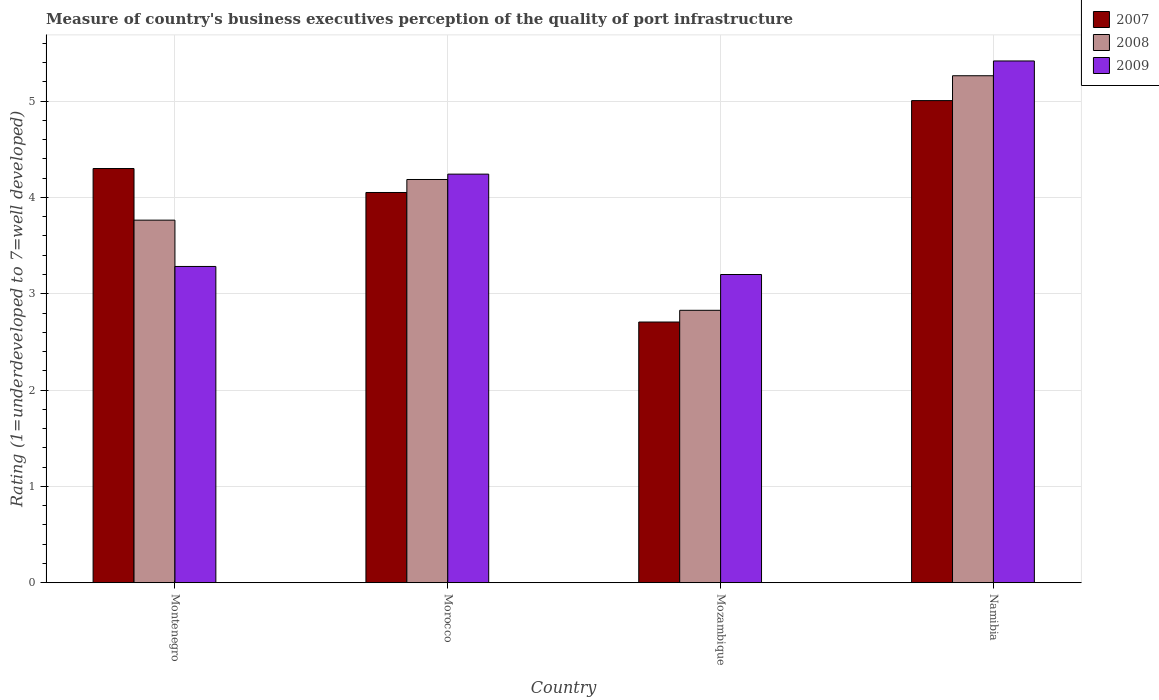How many groups of bars are there?
Give a very brief answer. 4. Are the number of bars on each tick of the X-axis equal?
Keep it short and to the point. Yes. How many bars are there on the 2nd tick from the left?
Your answer should be compact. 3. What is the label of the 1st group of bars from the left?
Your answer should be very brief. Montenegro. In how many cases, is the number of bars for a given country not equal to the number of legend labels?
Ensure brevity in your answer.  0. What is the ratings of the quality of port infrastructure in 2007 in Morocco?
Make the answer very short. 4.05. Across all countries, what is the maximum ratings of the quality of port infrastructure in 2009?
Give a very brief answer. 5.42. Across all countries, what is the minimum ratings of the quality of port infrastructure in 2009?
Offer a terse response. 3.2. In which country was the ratings of the quality of port infrastructure in 2007 maximum?
Give a very brief answer. Namibia. In which country was the ratings of the quality of port infrastructure in 2008 minimum?
Make the answer very short. Mozambique. What is the total ratings of the quality of port infrastructure in 2008 in the graph?
Keep it short and to the point. 16.04. What is the difference between the ratings of the quality of port infrastructure in 2009 in Montenegro and that in Mozambique?
Give a very brief answer. 0.08. What is the difference between the ratings of the quality of port infrastructure in 2009 in Montenegro and the ratings of the quality of port infrastructure in 2008 in Mozambique?
Give a very brief answer. 0.46. What is the average ratings of the quality of port infrastructure in 2008 per country?
Offer a very short reply. 4.01. What is the difference between the ratings of the quality of port infrastructure of/in 2008 and ratings of the quality of port infrastructure of/in 2007 in Montenegro?
Your answer should be very brief. -0.54. What is the ratio of the ratings of the quality of port infrastructure in 2007 in Montenegro to that in Namibia?
Your response must be concise. 0.86. Is the difference between the ratings of the quality of port infrastructure in 2008 in Montenegro and Namibia greater than the difference between the ratings of the quality of port infrastructure in 2007 in Montenegro and Namibia?
Offer a very short reply. No. What is the difference between the highest and the second highest ratings of the quality of port infrastructure in 2008?
Make the answer very short. -0.42. What is the difference between the highest and the lowest ratings of the quality of port infrastructure in 2009?
Keep it short and to the point. 2.22. In how many countries, is the ratings of the quality of port infrastructure in 2008 greater than the average ratings of the quality of port infrastructure in 2008 taken over all countries?
Your response must be concise. 2. Is it the case that in every country, the sum of the ratings of the quality of port infrastructure in 2008 and ratings of the quality of port infrastructure in 2009 is greater than the ratings of the quality of port infrastructure in 2007?
Provide a succinct answer. Yes. What is the difference between two consecutive major ticks on the Y-axis?
Your response must be concise. 1. What is the title of the graph?
Offer a very short reply. Measure of country's business executives perception of the quality of port infrastructure. What is the label or title of the Y-axis?
Offer a very short reply. Rating (1=underdeveloped to 7=well developed). What is the Rating (1=underdeveloped to 7=well developed) in 2007 in Montenegro?
Give a very brief answer. 4.3. What is the Rating (1=underdeveloped to 7=well developed) in 2008 in Montenegro?
Provide a short and direct response. 3.76. What is the Rating (1=underdeveloped to 7=well developed) of 2009 in Montenegro?
Ensure brevity in your answer.  3.28. What is the Rating (1=underdeveloped to 7=well developed) in 2007 in Morocco?
Give a very brief answer. 4.05. What is the Rating (1=underdeveloped to 7=well developed) of 2008 in Morocco?
Your answer should be very brief. 4.19. What is the Rating (1=underdeveloped to 7=well developed) of 2009 in Morocco?
Provide a short and direct response. 4.24. What is the Rating (1=underdeveloped to 7=well developed) of 2007 in Mozambique?
Ensure brevity in your answer.  2.71. What is the Rating (1=underdeveloped to 7=well developed) of 2008 in Mozambique?
Provide a succinct answer. 2.83. What is the Rating (1=underdeveloped to 7=well developed) of 2009 in Mozambique?
Offer a terse response. 3.2. What is the Rating (1=underdeveloped to 7=well developed) in 2007 in Namibia?
Offer a very short reply. 5.01. What is the Rating (1=underdeveloped to 7=well developed) of 2008 in Namibia?
Ensure brevity in your answer.  5.26. What is the Rating (1=underdeveloped to 7=well developed) of 2009 in Namibia?
Ensure brevity in your answer.  5.42. Across all countries, what is the maximum Rating (1=underdeveloped to 7=well developed) in 2007?
Your response must be concise. 5.01. Across all countries, what is the maximum Rating (1=underdeveloped to 7=well developed) in 2008?
Your answer should be very brief. 5.26. Across all countries, what is the maximum Rating (1=underdeveloped to 7=well developed) of 2009?
Ensure brevity in your answer.  5.42. Across all countries, what is the minimum Rating (1=underdeveloped to 7=well developed) of 2007?
Provide a short and direct response. 2.71. Across all countries, what is the minimum Rating (1=underdeveloped to 7=well developed) of 2008?
Provide a succinct answer. 2.83. Across all countries, what is the minimum Rating (1=underdeveloped to 7=well developed) in 2009?
Ensure brevity in your answer.  3.2. What is the total Rating (1=underdeveloped to 7=well developed) of 2007 in the graph?
Offer a very short reply. 16.06. What is the total Rating (1=underdeveloped to 7=well developed) in 2008 in the graph?
Provide a succinct answer. 16.04. What is the total Rating (1=underdeveloped to 7=well developed) of 2009 in the graph?
Give a very brief answer. 16.14. What is the difference between the Rating (1=underdeveloped to 7=well developed) of 2007 in Montenegro and that in Morocco?
Ensure brevity in your answer.  0.25. What is the difference between the Rating (1=underdeveloped to 7=well developed) of 2008 in Montenegro and that in Morocco?
Your answer should be very brief. -0.42. What is the difference between the Rating (1=underdeveloped to 7=well developed) in 2009 in Montenegro and that in Morocco?
Your response must be concise. -0.96. What is the difference between the Rating (1=underdeveloped to 7=well developed) in 2007 in Montenegro and that in Mozambique?
Give a very brief answer. 1.59. What is the difference between the Rating (1=underdeveloped to 7=well developed) of 2008 in Montenegro and that in Mozambique?
Offer a very short reply. 0.94. What is the difference between the Rating (1=underdeveloped to 7=well developed) in 2009 in Montenegro and that in Mozambique?
Your answer should be very brief. 0.08. What is the difference between the Rating (1=underdeveloped to 7=well developed) in 2007 in Montenegro and that in Namibia?
Provide a succinct answer. -0.71. What is the difference between the Rating (1=underdeveloped to 7=well developed) of 2008 in Montenegro and that in Namibia?
Offer a very short reply. -1.5. What is the difference between the Rating (1=underdeveloped to 7=well developed) in 2009 in Montenegro and that in Namibia?
Your response must be concise. -2.13. What is the difference between the Rating (1=underdeveloped to 7=well developed) of 2007 in Morocco and that in Mozambique?
Your answer should be compact. 1.34. What is the difference between the Rating (1=underdeveloped to 7=well developed) of 2008 in Morocco and that in Mozambique?
Keep it short and to the point. 1.36. What is the difference between the Rating (1=underdeveloped to 7=well developed) of 2009 in Morocco and that in Mozambique?
Provide a short and direct response. 1.04. What is the difference between the Rating (1=underdeveloped to 7=well developed) in 2007 in Morocco and that in Namibia?
Offer a terse response. -0.95. What is the difference between the Rating (1=underdeveloped to 7=well developed) of 2008 in Morocco and that in Namibia?
Ensure brevity in your answer.  -1.08. What is the difference between the Rating (1=underdeveloped to 7=well developed) of 2009 in Morocco and that in Namibia?
Give a very brief answer. -1.18. What is the difference between the Rating (1=underdeveloped to 7=well developed) in 2007 in Mozambique and that in Namibia?
Your answer should be compact. -2.3. What is the difference between the Rating (1=underdeveloped to 7=well developed) in 2008 in Mozambique and that in Namibia?
Your answer should be very brief. -2.44. What is the difference between the Rating (1=underdeveloped to 7=well developed) of 2009 in Mozambique and that in Namibia?
Offer a terse response. -2.22. What is the difference between the Rating (1=underdeveloped to 7=well developed) of 2007 in Montenegro and the Rating (1=underdeveloped to 7=well developed) of 2008 in Morocco?
Your answer should be very brief. 0.11. What is the difference between the Rating (1=underdeveloped to 7=well developed) of 2007 in Montenegro and the Rating (1=underdeveloped to 7=well developed) of 2009 in Morocco?
Offer a terse response. 0.06. What is the difference between the Rating (1=underdeveloped to 7=well developed) in 2008 in Montenegro and the Rating (1=underdeveloped to 7=well developed) in 2009 in Morocco?
Your answer should be compact. -0.48. What is the difference between the Rating (1=underdeveloped to 7=well developed) in 2007 in Montenegro and the Rating (1=underdeveloped to 7=well developed) in 2008 in Mozambique?
Provide a succinct answer. 1.47. What is the difference between the Rating (1=underdeveloped to 7=well developed) of 2007 in Montenegro and the Rating (1=underdeveloped to 7=well developed) of 2009 in Mozambique?
Your answer should be very brief. 1.1. What is the difference between the Rating (1=underdeveloped to 7=well developed) in 2008 in Montenegro and the Rating (1=underdeveloped to 7=well developed) in 2009 in Mozambique?
Keep it short and to the point. 0.56. What is the difference between the Rating (1=underdeveloped to 7=well developed) of 2007 in Montenegro and the Rating (1=underdeveloped to 7=well developed) of 2008 in Namibia?
Offer a terse response. -0.96. What is the difference between the Rating (1=underdeveloped to 7=well developed) in 2007 in Montenegro and the Rating (1=underdeveloped to 7=well developed) in 2009 in Namibia?
Offer a terse response. -1.12. What is the difference between the Rating (1=underdeveloped to 7=well developed) in 2008 in Montenegro and the Rating (1=underdeveloped to 7=well developed) in 2009 in Namibia?
Make the answer very short. -1.65. What is the difference between the Rating (1=underdeveloped to 7=well developed) of 2007 in Morocco and the Rating (1=underdeveloped to 7=well developed) of 2008 in Mozambique?
Give a very brief answer. 1.22. What is the difference between the Rating (1=underdeveloped to 7=well developed) in 2007 in Morocco and the Rating (1=underdeveloped to 7=well developed) in 2009 in Mozambique?
Offer a terse response. 0.85. What is the difference between the Rating (1=underdeveloped to 7=well developed) in 2008 in Morocco and the Rating (1=underdeveloped to 7=well developed) in 2009 in Mozambique?
Your response must be concise. 0.99. What is the difference between the Rating (1=underdeveloped to 7=well developed) of 2007 in Morocco and the Rating (1=underdeveloped to 7=well developed) of 2008 in Namibia?
Make the answer very short. -1.21. What is the difference between the Rating (1=underdeveloped to 7=well developed) of 2007 in Morocco and the Rating (1=underdeveloped to 7=well developed) of 2009 in Namibia?
Make the answer very short. -1.37. What is the difference between the Rating (1=underdeveloped to 7=well developed) of 2008 in Morocco and the Rating (1=underdeveloped to 7=well developed) of 2009 in Namibia?
Your answer should be very brief. -1.23. What is the difference between the Rating (1=underdeveloped to 7=well developed) of 2007 in Mozambique and the Rating (1=underdeveloped to 7=well developed) of 2008 in Namibia?
Make the answer very short. -2.56. What is the difference between the Rating (1=underdeveloped to 7=well developed) in 2007 in Mozambique and the Rating (1=underdeveloped to 7=well developed) in 2009 in Namibia?
Offer a very short reply. -2.71. What is the difference between the Rating (1=underdeveloped to 7=well developed) of 2008 in Mozambique and the Rating (1=underdeveloped to 7=well developed) of 2009 in Namibia?
Give a very brief answer. -2.59. What is the average Rating (1=underdeveloped to 7=well developed) of 2007 per country?
Offer a terse response. 4.02. What is the average Rating (1=underdeveloped to 7=well developed) of 2008 per country?
Ensure brevity in your answer.  4.01. What is the average Rating (1=underdeveloped to 7=well developed) of 2009 per country?
Make the answer very short. 4.04. What is the difference between the Rating (1=underdeveloped to 7=well developed) of 2007 and Rating (1=underdeveloped to 7=well developed) of 2008 in Montenegro?
Provide a short and direct response. 0.54. What is the difference between the Rating (1=underdeveloped to 7=well developed) in 2007 and Rating (1=underdeveloped to 7=well developed) in 2009 in Montenegro?
Provide a succinct answer. 1.02. What is the difference between the Rating (1=underdeveloped to 7=well developed) of 2008 and Rating (1=underdeveloped to 7=well developed) of 2009 in Montenegro?
Your answer should be compact. 0.48. What is the difference between the Rating (1=underdeveloped to 7=well developed) of 2007 and Rating (1=underdeveloped to 7=well developed) of 2008 in Morocco?
Provide a short and direct response. -0.13. What is the difference between the Rating (1=underdeveloped to 7=well developed) of 2007 and Rating (1=underdeveloped to 7=well developed) of 2009 in Morocco?
Offer a terse response. -0.19. What is the difference between the Rating (1=underdeveloped to 7=well developed) of 2008 and Rating (1=underdeveloped to 7=well developed) of 2009 in Morocco?
Keep it short and to the point. -0.06. What is the difference between the Rating (1=underdeveloped to 7=well developed) in 2007 and Rating (1=underdeveloped to 7=well developed) in 2008 in Mozambique?
Your answer should be compact. -0.12. What is the difference between the Rating (1=underdeveloped to 7=well developed) of 2007 and Rating (1=underdeveloped to 7=well developed) of 2009 in Mozambique?
Your response must be concise. -0.49. What is the difference between the Rating (1=underdeveloped to 7=well developed) in 2008 and Rating (1=underdeveloped to 7=well developed) in 2009 in Mozambique?
Keep it short and to the point. -0.37. What is the difference between the Rating (1=underdeveloped to 7=well developed) of 2007 and Rating (1=underdeveloped to 7=well developed) of 2008 in Namibia?
Offer a terse response. -0.26. What is the difference between the Rating (1=underdeveloped to 7=well developed) of 2007 and Rating (1=underdeveloped to 7=well developed) of 2009 in Namibia?
Provide a short and direct response. -0.41. What is the difference between the Rating (1=underdeveloped to 7=well developed) in 2008 and Rating (1=underdeveloped to 7=well developed) in 2009 in Namibia?
Your answer should be very brief. -0.15. What is the ratio of the Rating (1=underdeveloped to 7=well developed) in 2007 in Montenegro to that in Morocco?
Offer a very short reply. 1.06. What is the ratio of the Rating (1=underdeveloped to 7=well developed) in 2008 in Montenegro to that in Morocco?
Ensure brevity in your answer.  0.9. What is the ratio of the Rating (1=underdeveloped to 7=well developed) in 2009 in Montenegro to that in Morocco?
Provide a short and direct response. 0.77. What is the ratio of the Rating (1=underdeveloped to 7=well developed) in 2007 in Montenegro to that in Mozambique?
Your answer should be compact. 1.59. What is the ratio of the Rating (1=underdeveloped to 7=well developed) in 2008 in Montenegro to that in Mozambique?
Offer a very short reply. 1.33. What is the ratio of the Rating (1=underdeveloped to 7=well developed) in 2009 in Montenegro to that in Mozambique?
Ensure brevity in your answer.  1.03. What is the ratio of the Rating (1=underdeveloped to 7=well developed) of 2007 in Montenegro to that in Namibia?
Provide a succinct answer. 0.86. What is the ratio of the Rating (1=underdeveloped to 7=well developed) of 2008 in Montenegro to that in Namibia?
Offer a very short reply. 0.72. What is the ratio of the Rating (1=underdeveloped to 7=well developed) of 2009 in Montenegro to that in Namibia?
Keep it short and to the point. 0.61. What is the ratio of the Rating (1=underdeveloped to 7=well developed) in 2007 in Morocco to that in Mozambique?
Offer a terse response. 1.5. What is the ratio of the Rating (1=underdeveloped to 7=well developed) of 2008 in Morocco to that in Mozambique?
Offer a very short reply. 1.48. What is the ratio of the Rating (1=underdeveloped to 7=well developed) of 2009 in Morocco to that in Mozambique?
Give a very brief answer. 1.33. What is the ratio of the Rating (1=underdeveloped to 7=well developed) of 2007 in Morocco to that in Namibia?
Make the answer very short. 0.81. What is the ratio of the Rating (1=underdeveloped to 7=well developed) of 2008 in Morocco to that in Namibia?
Provide a succinct answer. 0.8. What is the ratio of the Rating (1=underdeveloped to 7=well developed) in 2009 in Morocco to that in Namibia?
Offer a terse response. 0.78. What is the ratio of the Rating (1=underdeveloped to 7=well developed) of 2007 in Mozambique to that in Namibia?
Ensure brevity in your answer.  0.54. What is the ratio of the Rating (1=underdeveloped to 7=well developed) of 2008 in Mozambique to that in Namibia?
Ensure brevity in your answer.  0.54. What is the ratio of the Rating (1=underdeveloped to 7=well developed) in 2009 in Mozambique to that in Namibia?
Your response must be concise. 0.59. What is the difference between the highest and the second highest Rating (1=underdeveloped to 7=well developed) in 2007?
Your response must be concise. 0.71. What is the difference between the highest and the second highest Rating (1=underdeveloped to 7=well developed) in 2008?
Give a very brief answer. 1.08. What is the difference between the highest and the second highest Rating (1=underdeveloped to 7=well developed) in 2009?
Offer a very short reply. 1.18. What is the difference between the highest and the lowest Rating (1=underdeveloped to 7=well developed) of 2007?
Provide a succinct answer. 2.3. What is the difference between the highest and the lowest Rating (1=underdeveloped to 7=well developed) of 2008?
Give a very brief answer. 2.44. What is the difference between the highest and the lowest Rating (1=underdeveloped to 7=well developed) of 2009?
Provide a short and direct response. 2.22. 